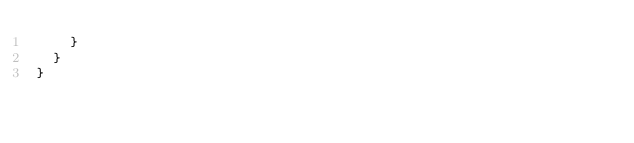Convert code to text. <code><loc_0><loc_0><loc_500><loc_500><_JavaScript_>    }
  }
}
</code> 